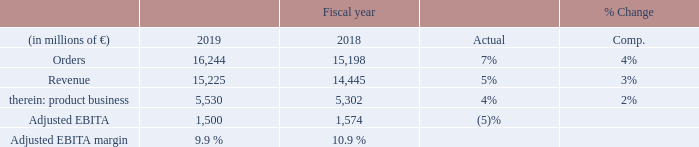Orders and revenue for Smart Infrastructure rose in all three businesses – solutions and services, systems and software, and the products business – and in all three reporting regions. Order growth was strongest in the solutions and services business on a sharply higher volume from large orders in the Americas and Europe, C. I. S., Africa, Middle East. Revenue rose most strongly in the systems and software and the solutions and services businesses, particularly in the Americas. Revenue growth in the product business was due to low voltage products, while revenue in the other products businesses came in close to prior-year levels due partly to less favorable conditions in short-cycle markets.
Adjusted EBITA declined due mainly to the systems and software business including negative effects related to grid control projects early in the year. Adjusted EBITA also included higher expenses year-over-year related to expansion of smart building offerings and for grid edge activities. Severance charges were € 48 million in fiscal 2019 compared to € 34 million a year earlier. Smart Infrastructure’s order backlog was € 10 billion at the end of the fiscal year, of which € 7 billion are expected to be converted into revenue in fiscal 2020.
Smart Infrastructure achieved its results in overall moderately growing markets in fiscal 2019. The grid markets benefited from the need for intelligent and flexible energy networks and for automation, particularly in Asia, Australia and the Americas. Heavy industries and the infrastructure industry also developed favorably during fiscal 2019, driven by investments in oil and gas markets, in data centers and in transportation infrastructure, such as for e-mobility. Discrete industries, which started strong
in fiscal 2019, experienced a downturn in the second half of the fiscal year.
Construction markets continued their stable growth during the fiscal year, particularly in the U. S. and China and in the non-residential construction market overall. Growth in the important building electrification and automation market was driven by demand for building performance and sustainability offerings, including strong demand for energy efficiency and digital services. In fiscal 2020, market growth overall is expected to
be lower than in fiscal 2019, due to an expected continuation of the downturn in the short-cycle markets, economic uncertainty in a number of countries due to trade conflicts, and other factors.
Beginning with fiscal 2020, the distribution transformer business will be transferred to the Operating Company Gas and Power. If this organizational structure had already existed in fiscal 2019, Smart Infrastructure would have posted orders of € 15.590 billion, revenue of € 14.597 billion, Adjusted EBITA of € 1.465 billion and an Adjusted EBITA margin of 10.0 %.
What was the reason for the decline in the Adjusted EBITDA? Adjusted ebita declined due mainly to the systems and software business including negative effects related to grid control projects early in the year. What drove the growth in the important building electrification and automation market? Driven by demand for building performance and sustainability offerings, including strong demand for energy efficiency and digital services. If the new organizational structure had already existed in fiscal 2019, Smart Infrastructure would have posted what revenue in 2019?  € 14.597 billion. What was the average orders for 2019 and 2018?
Answer scale should be: million. (16,244 + 15,198) / 2
Answer: 15721. What it the increase / (decrease) in revenue from 2018 to 2019?
Answer scale should be: million. (15,225 - 14,445)
Answer: 780. What is the increase / (decrease) in the Adjusted EBITDA margin from 2018 to 2019?
Answer scale should be: percent. 9.9% - 10.9%
Answer: -1. 